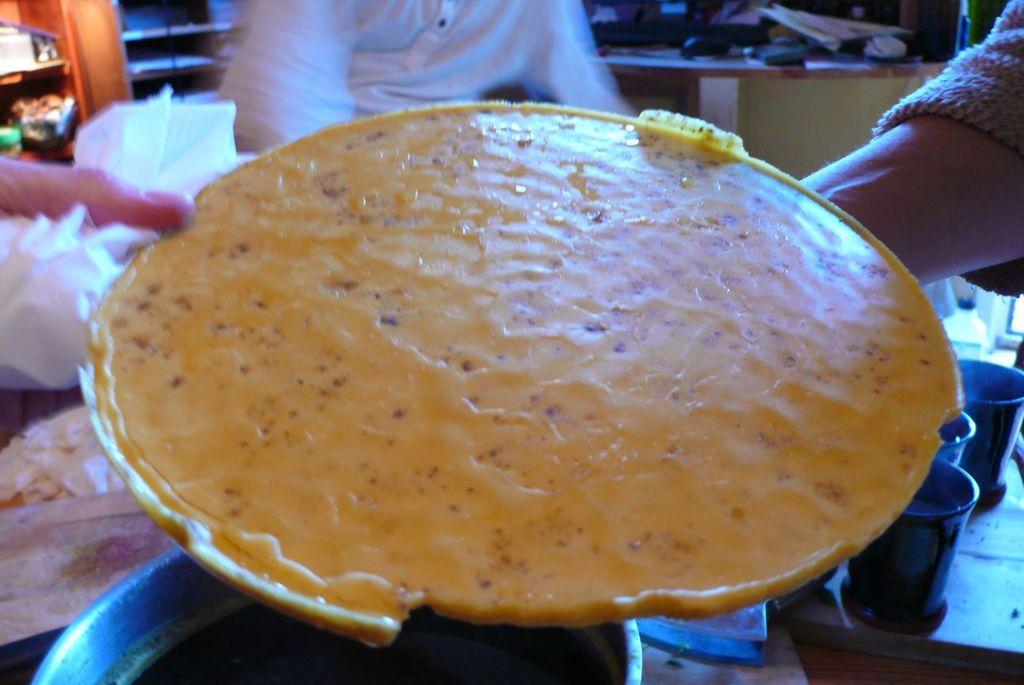Describe this image in one or two sentences. In this picture, we see the person holding the food item. It is in yellow color. At the bottom, we see the vessels and tins are placed on the table. On the left side, we see the hand of the person holding the tissue papers. Behind that, we see a rack in which objects are placed. At the top, we see a man in white T-shirt is standing. Behind him, we see a table on which papers, landline phone and some other objects are placed. 